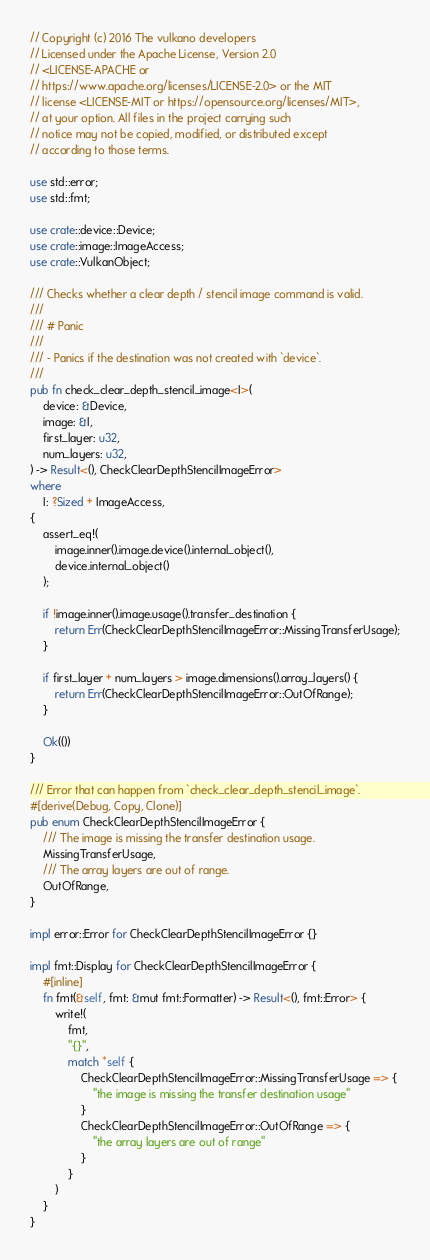Convert code to text. <code><loc_0><loc_0><loc_500><loc_500><_Rust_>// Copyright (c) 2016 The vulkano developers
// Licensed under the Apache License, Version 2.0
// <LICENSE-APACHE or
// https://www.apache.org/licenses/LICENSE-2.0> or the MIT
// license <LICENSE-MIT or https://opensource.org/licenses/MIT>,
// at your option. All files in the project carrying such
// notice may not be copied, modified, or distributed except
// according to those terms.

use std::error;
use std::fmt;

use crate::device::Device;
use crate::image::ImageAccess;
use crate::VulkanObject;

/// Checks whether a clear depth / stencil image command is valid.
///
/// # Panic
///
/// - Panics if the destination was not created with `device`.
///
pub fn check_clear_depth_stencil_image<I>(
    device: &Device,
    image: &I,
    first_layer: u32,
    num_layers: u32,
) -> Result<(), CheckClearDepthStencilImageError>
where
    I: ?Sized + ImageAccess,
{
    assert_eq!(
        image.inner().image.device().internal_object(),
        device.internal_object()
    );

    if !image.inner().image.usage().transfer_destination {
        return Err(CheckClearDepthStencilImageError::MissingTransferUsage);
    }

    if first_layer + num_layers > image.dimensions().array_layers() {
        return Err(CheckClearDepthStencilImageError::OutOfRange);
    }

    Ok(())
}

/// Error that can happen from `check_clear_depth_stencil_image`.
#[derive(Debug, Copy, Clone)]
pub enum CheckClearDepthStencilImageError {
    /// The image is missing the transfer destination usage.
    MissingTransferUsage,
    /// The array layers are out of range.
    OutOfRange,
}

impl error::Error for CheckClearDepthStencilImageError {}

impl fmt::Display for CheckClearDepthStencilImageError {
    #[inline]
    fn fmt(&self, fmt: &mut fmt::Formatter) -> Result<(), fmt::Error> {
        write!(
            fmt,
            "{}",
            match *self {
                CheckClearDepthStencilImageError::MissingTransferUsage => {
                    "the image is missing the transfer destination usage"
                }
                CheckClearDepthStencilImageError::OutOfRange => {
                    "the array layers are out of range"
                }
            }
        )
    }
}
</code> 